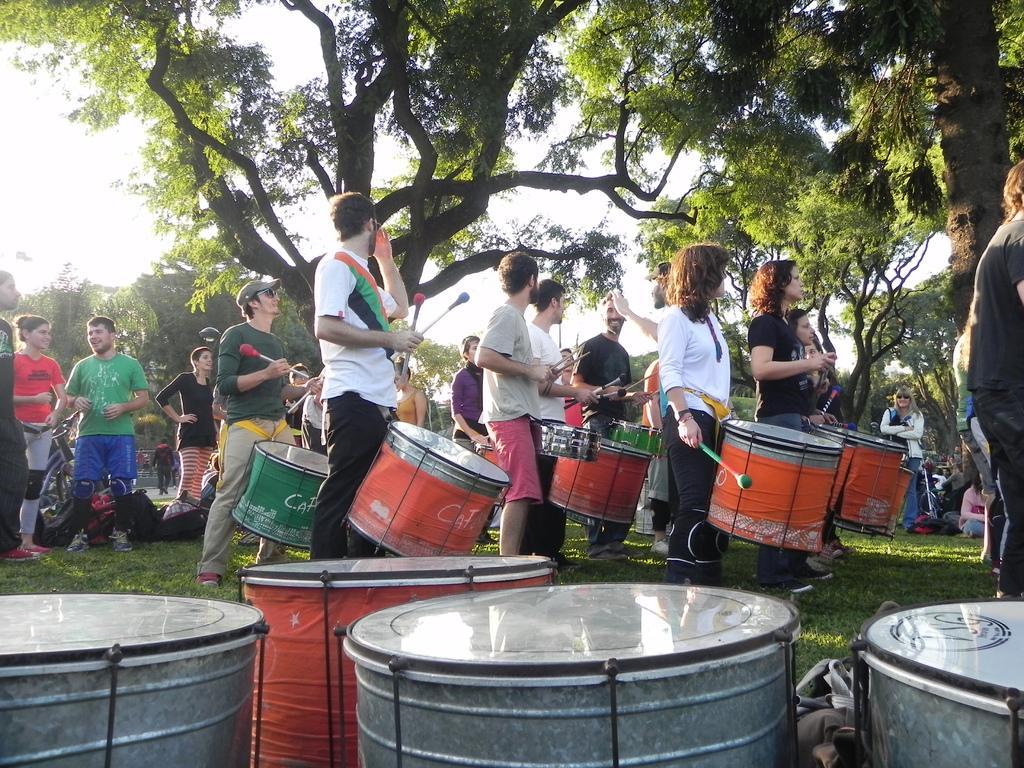Could you give a brief overview of what you see in this image? In the middle of the image few people are standing and playing some musical instruments. Bottom of the image few drums on the grass. Top of the image there are some trees. Bottom left side of the image few people are standing. 